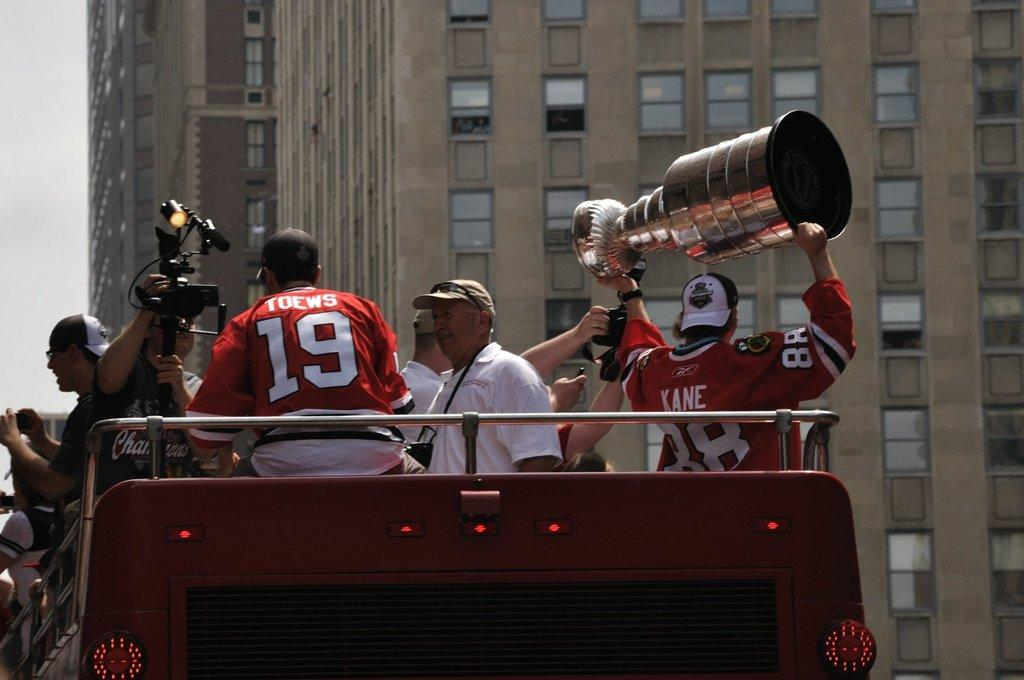<image>
Render a clear and concise summary of the photo. Hockey player wearing a Kane jersey holding up a trophy. 